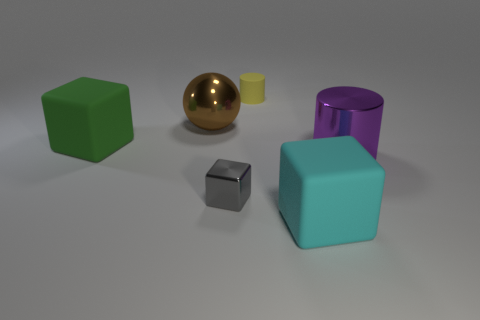Add 1 matte cylinders. How many objects exist? 7 Subtract all spheres. How many objects are left? 5 Add 1 large purple cylinders. How many large purple cylinders are left? 2 Add 4 small red matte cylinders. How many small red matte cylinders exist? 4 Subtract 0 brown blocks. How many objects are left? 6 Subtract all tiny cylinders. Subtract all cyan cubes. How many objects are left? 4 